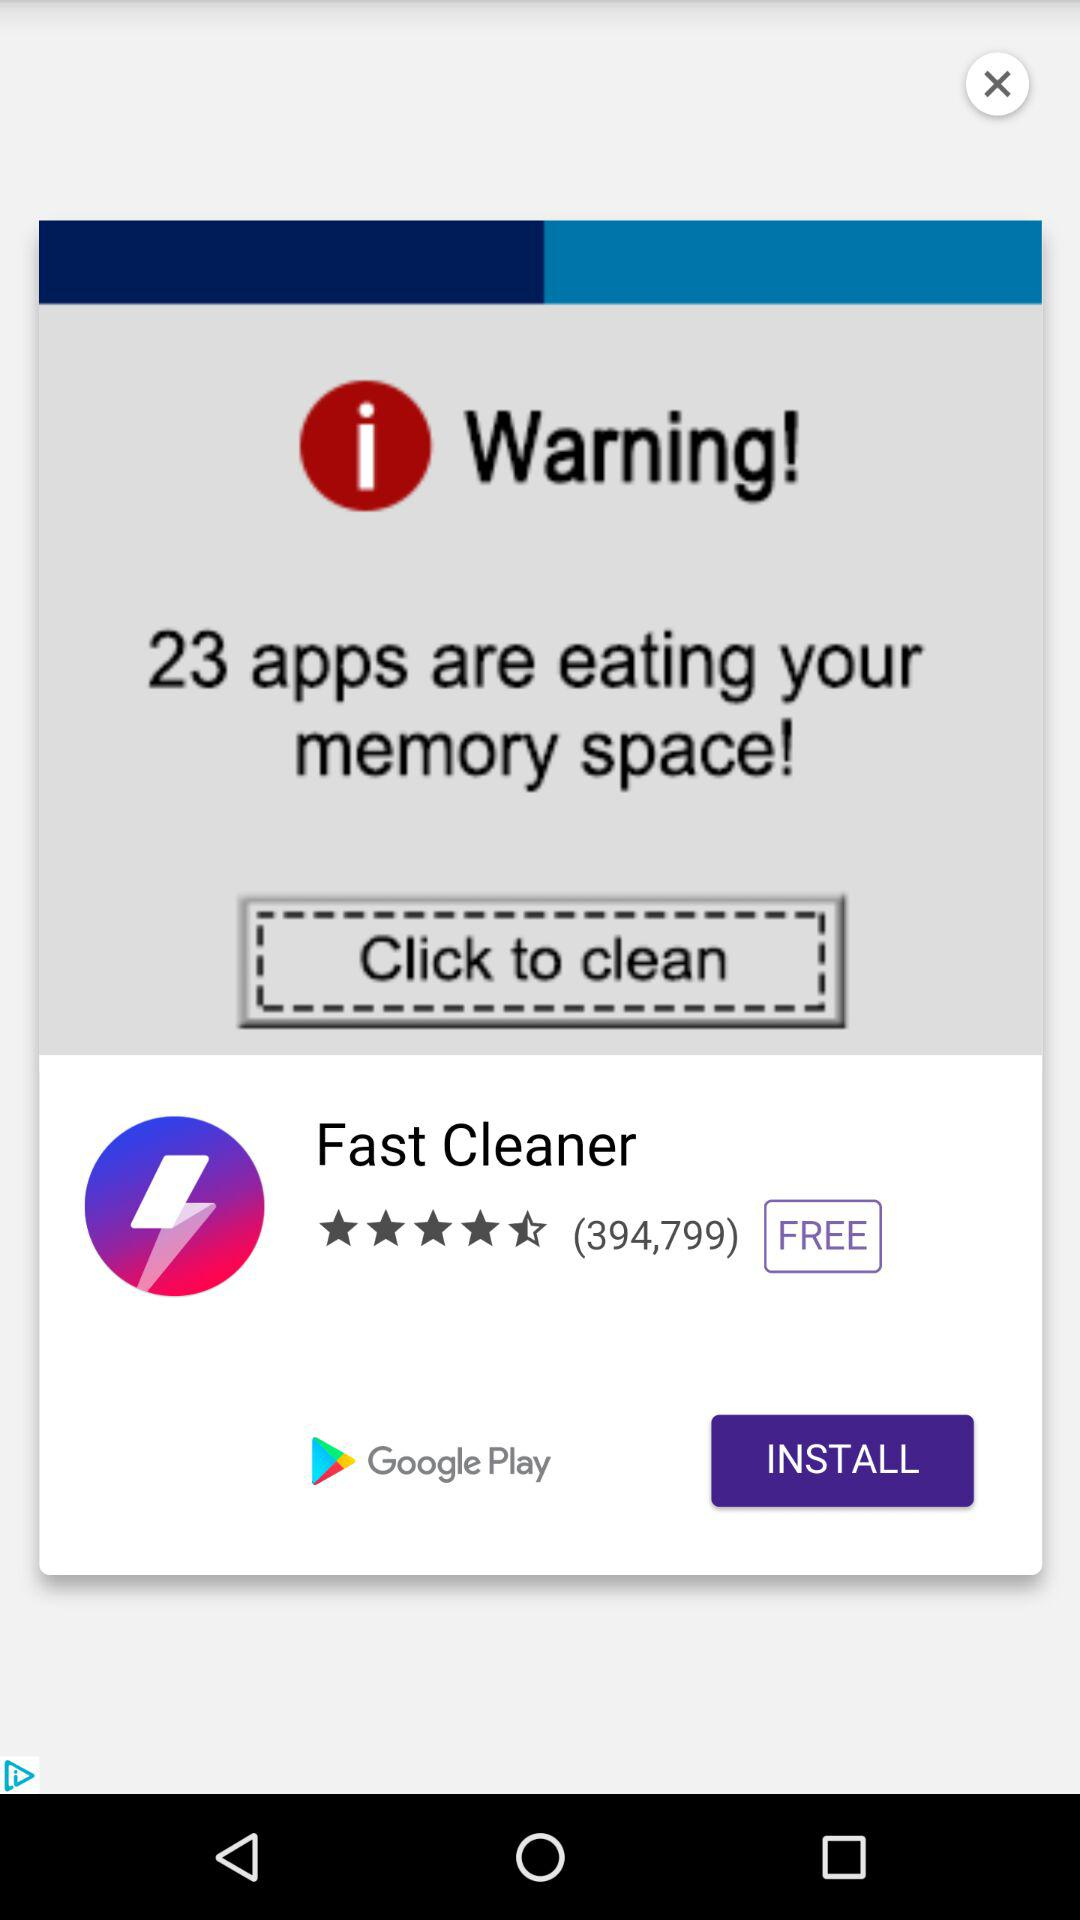How many apps are eating up memory space?
Answer the question using a single word or phrase. 23 